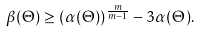Convert formula to latex. <formula><loc_0><loc_0><loc_500><loc_500>\beta ( \Theta ) \geq ( \alpha ( \Theta ) ) ^ { \frac { m } { m - 1 } } - 3 \alpha ( \Theta ) .</formula> 